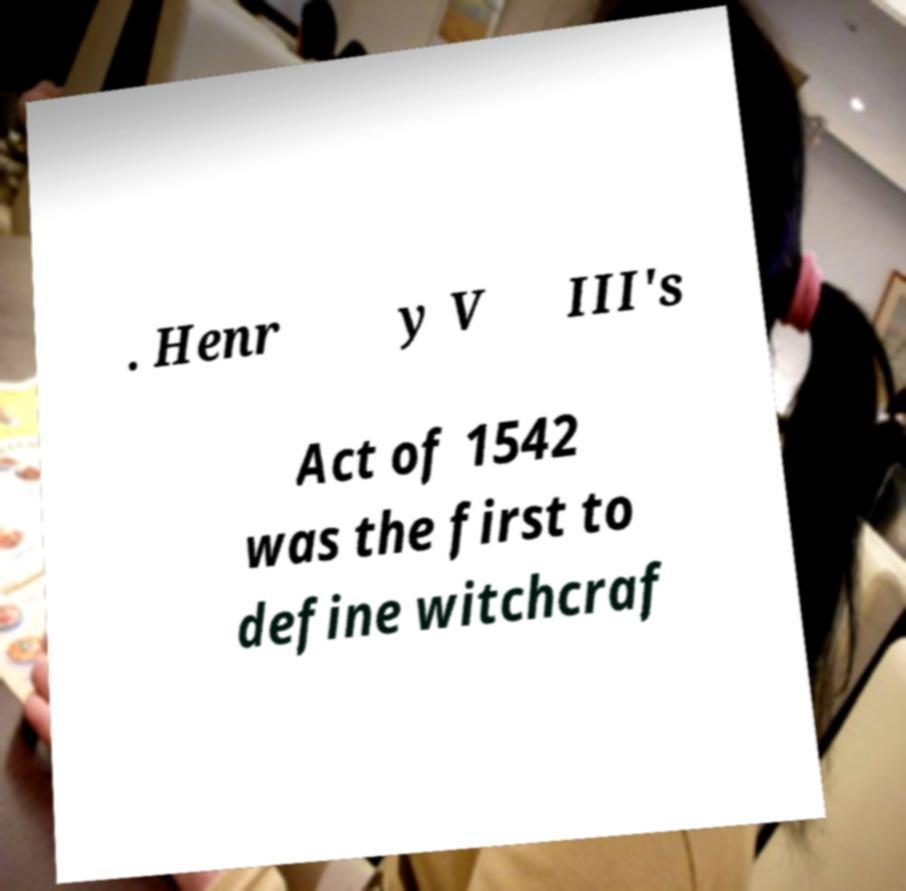Can you read and provide the text displayed in the image?This photo seems to have some interesting text. Can you extract and type it out for me? . Henr y V III's Act of 1542 was the first to define witchcraf 